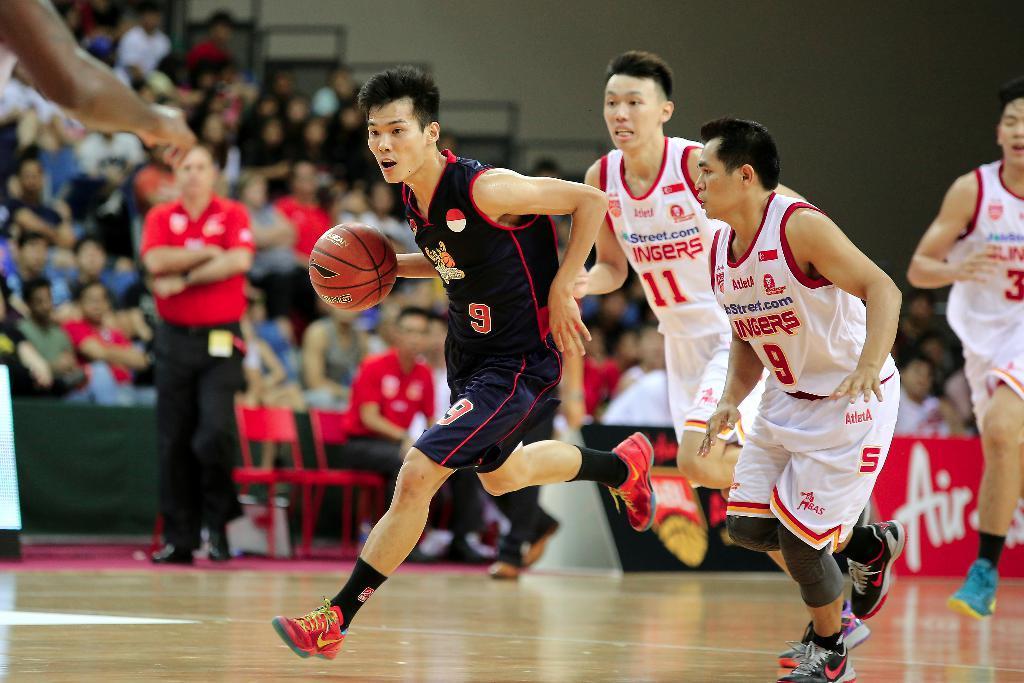Could you give a brief overview of what you see in this image? In this picture there is a man who is wearing black dress and he is holding basketball. Beside him we can see opposition player were wearing white dress and shoe. On the left there is a man who is wearing a white t-shirt, trouser and shoe. He is standing near to the chairs. In the background we can see the audience who are watching the game and sitting on the chair. At the top there is a wall. 